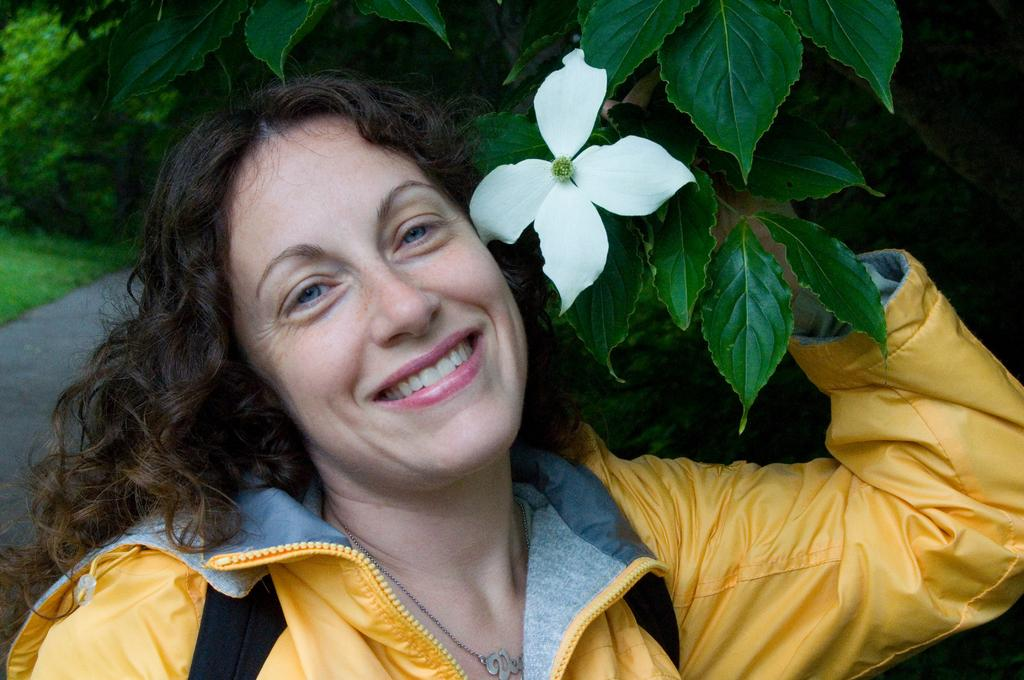Who is present in the image? There is a woman in the image. What is the woman doing in the image? The woman is standing and holding a tree branch. What can be seen in the image besides the woman? There is a flower, leaves, another tree in the background, and grass on the ground in the image. What is the woman teaching in the image? There is no indication in the image that the woman is teaching anything. 